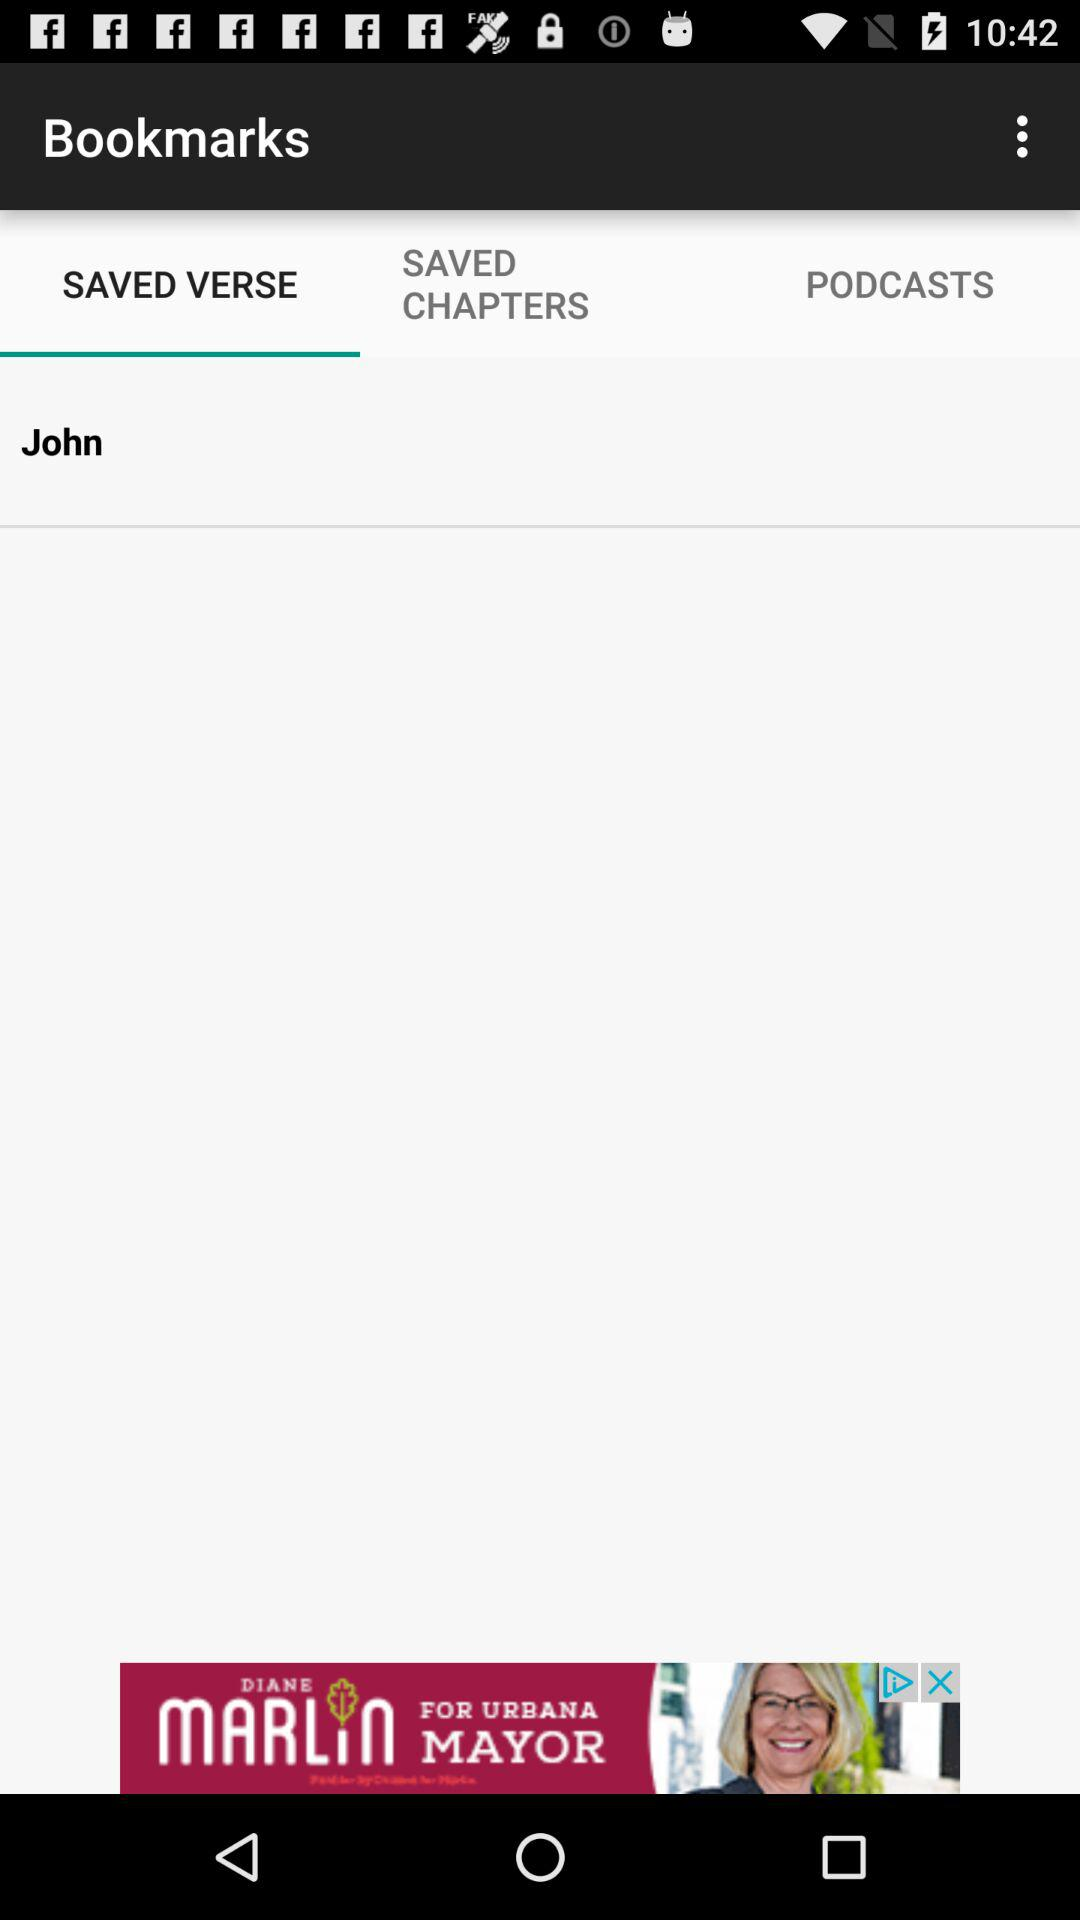What are the saved chapters?
When the provided information is insufficient, respond with <no answer>. <no answer> 